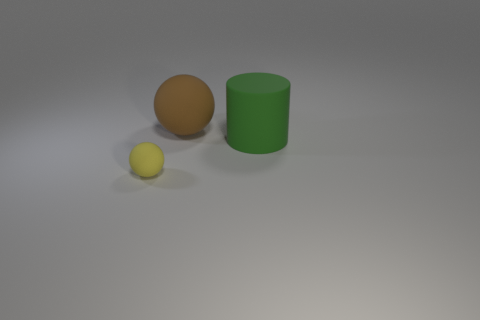Add 3 yellow matte objects. How many objects exist? 6 Subtract 0 purple spheres. How many objects are left? 3 Subtract all cylinders. How many objects are left? 2 Subtract 1 cylinders. How many cylinders are left? 0 Subtract all gray cylinders. Subtract all purple blocks. How many cylinders are left? 1 Subtract all green cubes. How many yellow balls are left? 1 Subtract all tiny yellow things. Subtract all matte cylinders. How many objects are left? 1 Add 1 brown rubber things. How many brown rubber things are left? 2 Add 1 blue cubes. How many blue cubes exist? 1 